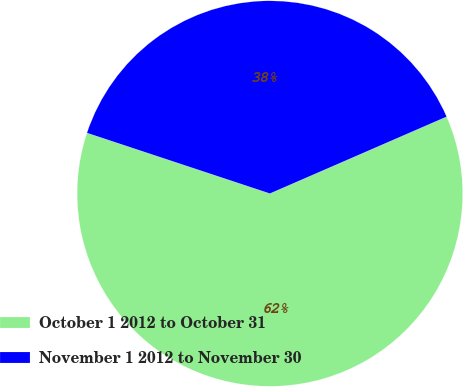Convert chart. <chart><loc_0><loc_0><loc_500><loc_500><pie_chart><fcel>October 1 2012 to October 31<fcel>November 1 2012 to November 30<nl><fcel>61.62%<fcel>38.38%<nl></chart> 